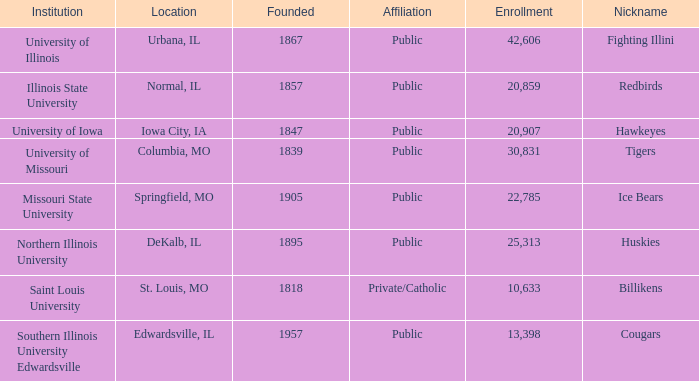What is the usual student enrollment at the redbirds' school? 20859.0. 